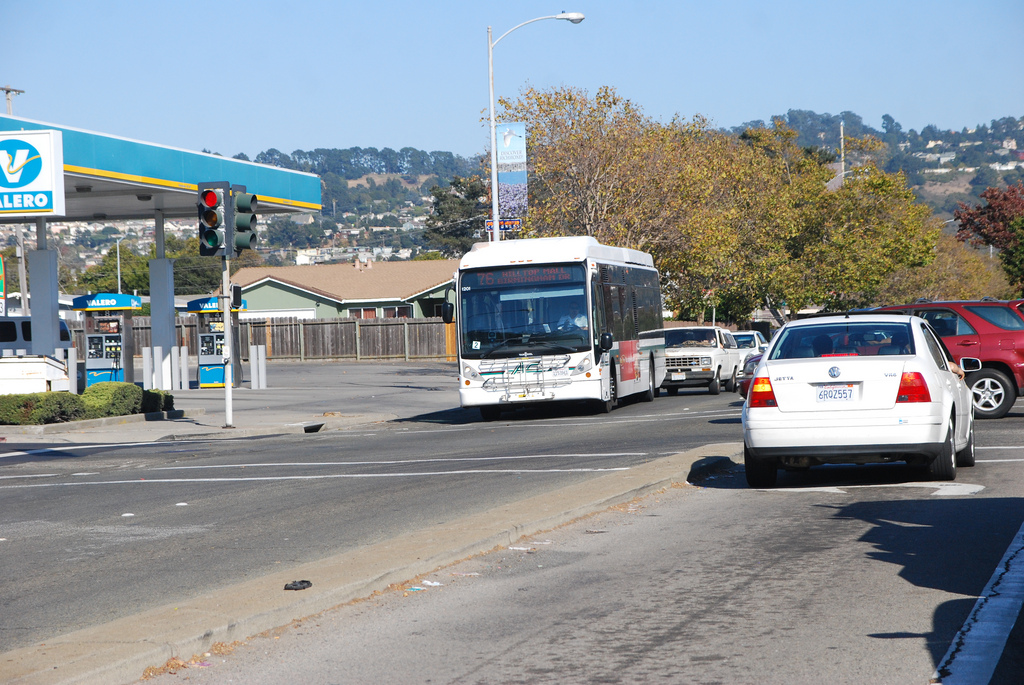What are the weather conditions implied by the image? The clear blue sky, bright sunlight, and absence of precipitation suggest that the weather is fair and sunny. 